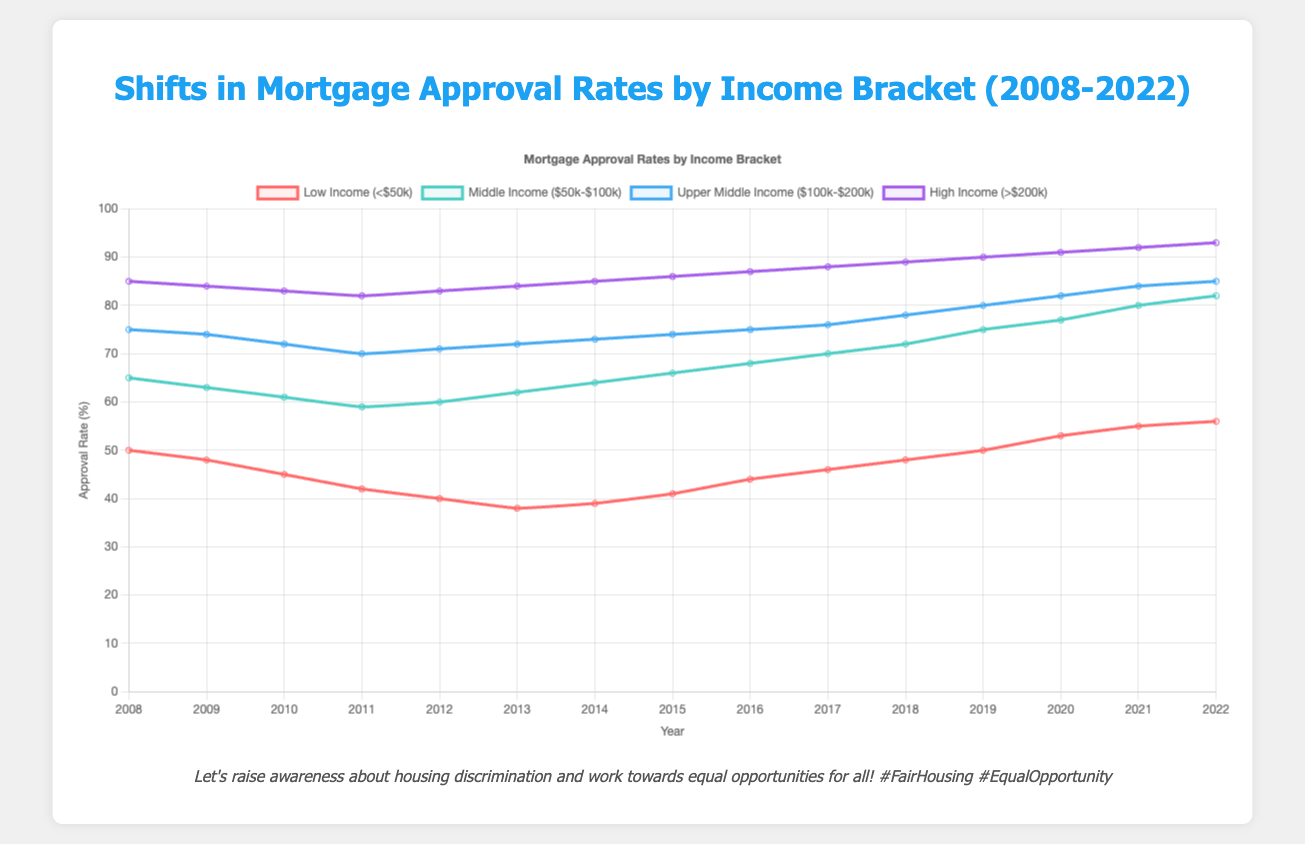What trend do you see in the mortgage approval rates for Low Income (<$50k) from 2008 to 2022? The mortgage approval rates for Low Income have generally increased over the years. It started at 50% in 2008, dropped to a low of 38% in 2013, and then rose to 56% by 2022.
Answer: Increase By how many percentage points did the mortgage approval rate for Middle Income ($50k-$100k) change from 2008 to 2022? The mortgage approval rate for Middle Income in 2008 was 65%, and in 2022 it was 82%. The change is 82% - 65% = 17 percentage points.
Answer: 17 percentage points Which income bracket had the smallest increase in mortgage approval rates from 2008 to 2022? Comparing the changes for each bracket: Low Income increased by 6 percentage points (56% - 50%), Middle Income by 17 percentage points (82% - 65%), Upper Middle Income by 10 percentage points (85% - 75%), and High Income by 8 percentage points (93% - 85%). The Low Income bracket had the smallest increase.
Answer: Low Income How did the mortgage approval rates for High Income (>$200k) change from 2012 to 2015? In 2012, the approval rate for High Income was 83%, and in 2015 it was 86%. The change is 86% - 83% = 3 percentage points increase over the period.
Answer: 3 percentage points increase In which year did the mortgage approval rate for Upper Middle Income ($100k-$200k) equal 75%, and what was the rate for Low Income (<$50k) that same year? The approval rate for Upper Middle Income was 75% in 2016. In 2016, the rate for Low Income was 44%.
Answer: 2016, 44% What is the average mortgage approval rate for Middle Income ($50k-$100k) over the entire period (2008-2022)? The average is calculated by summing all values and dividing by the number of years: (65 + 63 + 61 + 59 + 60 + 62 + 64 + 66 + 68 + 70 + 72 + 75 + 77 + 80 + 82) / 15 = 67.13%.
Answer: 67.13% Which income bracket had the highest approval rate in 2020, and what was the rate? In 2020, the High Income (>$200k) bracket had the highest approval rate at 91%.
Answer: High Income, 91% 